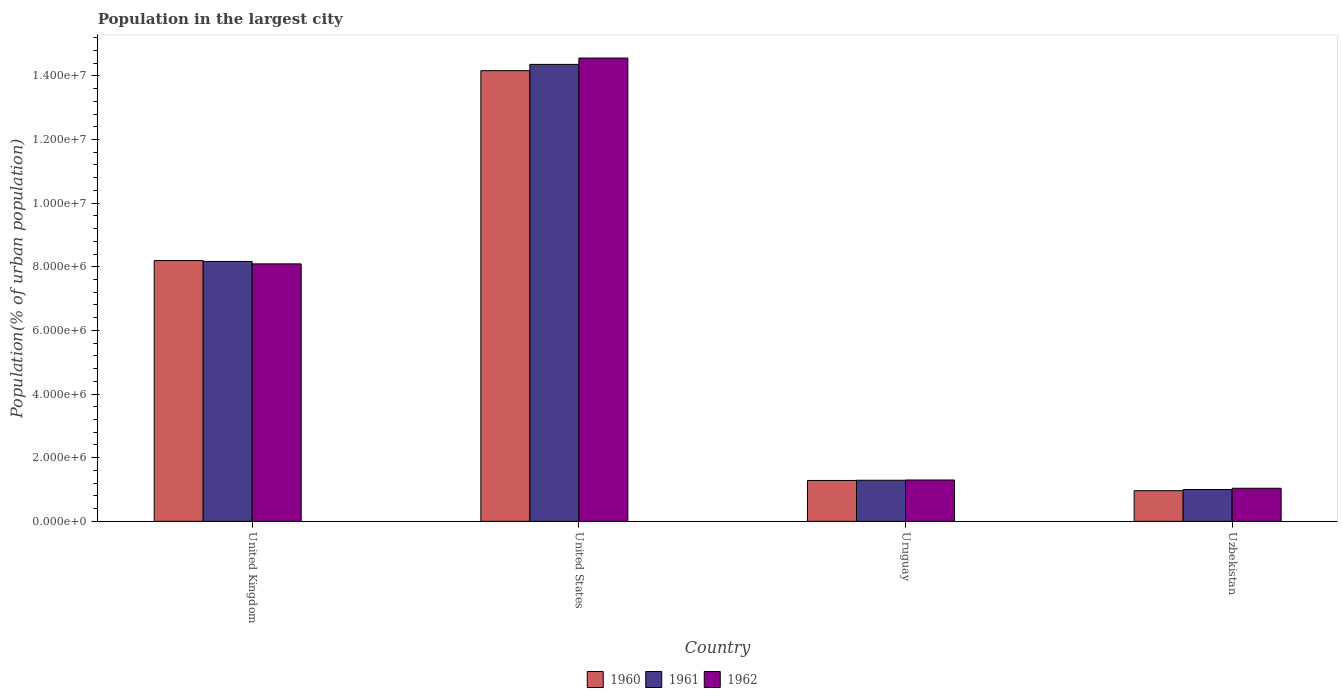Are the number of bars per tick equal to the number of legend labels?
Your answer should be very brief. Yes. Are the number of bars on each tick of the X-axis equal?
Offer a terse response. Yes. How many bars are there on the 1st tick from the left?
Give a very brief answer. 3. How many bars are there on the 2nd tick from the right?
Offer a terse response. 3. What is the label of the 1st group of bars from the left?
Keep it short and to the point. United Kingdom. In how many cases, is the number of bars for a given country not equal to the number of legend labels?
Provide a short and direct response. 0. What is the population in the largest city in 1961 in Uruguay?
Keep it short and to the point. 1.29e+06. Across all countries, what is the maximum population in the largest city in 1961?
Offer a terse response. 1.44e+07. Across all countries, what is the minimum population in the largest city in 1960?
Your answer should be very brief. 9.64e+05. In which country was the population in the largest city in 1962 minimum?
Keep it short and to the point. Uzbekistan. What is the total population in the largest city in 1960 in the graph?
Offer a terse response. 2.46e+07. What is the difference between the population in the largest city in 1960 in United Kingdom and that in Uruguay?
Ensure brevity in your answer.  6.91e+06. What is the difference between the population in the largest city in 1960 in United Kingdom and the population in the largest city in 1961 in Uruguay?
Offer a terse response. 6.90e+06. What is the average population in the largest city in 1961 per country?
Make the answer very short. 6.21e+06. What is the difference between the population in the largest city of/in 1962 and population in the largest city of/in 1960 in United States?
Give a very brief answer. 3.97e+05. What is the ratio of the population in the largest city in 1961 in Uruguay to that in Uzbekistan?
Keep it short and to the point. 1.29. Is the population in the largest city in 1962 in United Kingdom less than that in Uruguay?
Give a very brief answer. No. Is the difference between the population in the largest city in 1962 in Uruguay and Uzbekistan greater than the difference between the population in the largest city in 1960 in Uruguay and Uzbekistan?
Give a very brief answer. No. What is the difference between the highest and the second highest population in the largest city in 1960?
Provide a short and direct response. 5.97e+06. What is the difference between the highest and the lowest population in the largest city in 1960?
Your answer should be compact. 1.32e+07. Is the sum of the population in the largest city in 1961 in United Kingdom and United States greater than the maximum population in the largest city in 1960 across all countries?
Provide a short and direct response. Yes. What does the 3rd bar from the left in Uruguay represents?
Your answer should be very brief. 1962. What does the 3rd bar from the right in United States represents?
Offer a very short reply. 1960. Is it the case that in every country, the sum of the population in the largest city in 1960 and population in the largest city in 1961 is greater than the population in the largest city in 1962?
Provide a succinct answer. Yes. Are all the bars in the graph horizontal?
Offer a very short reply. No. What is the difference between two consecutive major ticks on the Y-axis?
Provide a short and direct response. 2.00e+06. Does the graph contain any zero values?
Your answer should be very brief. No. Does the graph contain grids?
Provide a succinct answer. No. Where does the legend appear in the graph?
Provide a short and direct response. Bottom center. How many legend labels are there?
Give a very brief answer. 3. How are the legend labels stacked?
Your response must be concise. Horizontal. What is the title of the graph?
Make the answer very short. Population in the largest city. What is the label or title of the Y-axis?
Offer a terse response. Population(% of urban population). What is the Population(% of urban population) of 1960 in United Kingdom?
Provide a succinct answer. 8.20e+06. What is the Population(% of urban population) of 1961 in United Kingdom?
Keep it short and to the point. 8.17e+06. What is the Population(% of urban population) of 1962 in United Kingdom?
Offer a very short reply. 8.09e+06. What is the Population(% of urban population) of 1960 in United States?
Your answer should be compact. 1.42e+07. What is the Population(% of urban population) in 1961 in United States?
Offer a terse response. 1.44e+07. What is the Population(% of urban population) in 1962 in United States?
Your response must be concise. 1.46e+07. What is the Population(% of urban population) of 1960 in Uruguay?
Ensure brevity in your answer.  1.28e+06. What is the Population(% of urban population) of 1961 in Uruguay?
Offer a terse response. 1.29e+06. What is the Population(% of urban population) of 1962 in Uruguay?
Ensure brevity in your answer.  1.30e+06. What is the Population(% of urban population) of 1960 in Uzbekistan?
Provide a short and direct response. 9.64e+05. What is the Population(% of urban population) in 1961 in Uzbekistan?
Make the answer very short. 1.00e+06. What is the Population(% of urban population) in 1962 in Uzbekistan?
Keep it short and to the point. 1.04e+06. Across all countries, what is the maximum Population(% of urban population) of 1960?
Give a very brief answer. 1.42e+07. Across all countries, what is the maximum Population(% of urban population) of 1961?
Offer a terse response. 1.44e+07. Across all countries, what is the maximum Population(% of urban population) of 1962?
Keep it short and to the point. 1.46e+07. Across all countries, what is the minimum Population(% of urban population) in 1960?
Your response must be concise. 9.64e+05. Across all countries, what is the minimum Population(% of urban population) in 1961?
Provide a short and direct response. 1.00e+06. Across all countries, what is the minimum Population(% of urban population) in 1962?
Your answer should be compact. 1.04e+06. What is the total Population(% of urban population) in 1960 in the graph?
Keep it short and to the point. 2.46e+07. What is the total Population(% of urban population) in 1961 in the graph?
Provide a succinct answer. 2.48e+07. What is the total Population(% of urban population) of 1962 in the graph?
Your response must be concise. 2.50e+07. What is the difference between the Population(% of urban population) in 1960 in United Kingdom and that in United States?
Make the answer very short. -5.97e+06. What is the difference between the Population(% of urban population) of 1961 in United Kingdom and that in United States?
Your answer should be compact. -6.19e+06. What is the difference between the Population(% of urban population) of 1962 in United Kingdom and that in United States?
Offer a very short reply. -6.47e+06. What is the difference between the Population(% of urban population) of 1960 in United Kingdom and that in Uruguay?
Give a very brief answer. 6.91e+06. What is the difference between the Population(% of urban population) in 1961 in United Kingdom and that in Uruguay?
Keep it short and to the point. 6.88e+06. What is the difference between the Population(% of urban population) of 1962 in United Kingdom and that in Uruguay?
Provide a short and direct response. 6.79e+06. What is the difference between the Population(% of urban population) in 1960 in United Kingdom and that in Uzbekistan?
Your answer should be compact. 7.23e+06. What is the difference between the Population(% of urban population) of 1961 in United Kingdom and that in Uzbekistan?
Your answer should be compact. 7.17e+06. What is the difference between the Population(% of urban population) of 1962 in United Kingdom and that in Uzbekistan?
Your response must be concise. 7.05e+06. What is the difference between the Population(% of urban population) in 1960 in United States and that in Uruguay?
Offer a terse response. 1.29e+07. What is the difference between the Population(% of urban population) of 1961 in United States and that in Uruguay?
Offer a very short reply. 1.31e+07. What is the difference between the Population(% of urban population) in 1962 in United States and that in Uruguay?
Ensure brevity in your answer.  1.33e+07. What is the difference between the Population(% of urban population) in 1960 in United States and that in Uzbekistan?
Your answer should be very brief. 1.32e+07. What is the difference between the Population(% of urban population) of 1961 in United States and that in Uzbekistan?
Make the answer very short. 1.34e+07. What is the difference between the Population(% of urban population) in 1962 in United States and that in Uzbekistan?
Provide a short and direct response. 1.35e+07. What is the difference between the Population(% of urban population) in 1960 in Uruguay and that in Uzbekistan?
Your response must be concise. 3.21e+05. What is the difference between the Population(% of urban population) in 1961 in Uruguay and that in Uzbekistan?
Provide a short and direct response. 2.91e+05. What is the difference between the Population(% of urban population) in 1962 in Uruguay and that in Uzbekistan?
Offer a terse response. 2.60e+05. What is the difference between the Population(% of urban population) in 1960 in United Kingdom and the Population(% of urban population) in 1961 in United States?
Make the answer very short. -6.16e+06. What is the difference between the Population(% of urban population) in 1960 in United Kingdom and the Population(% of urban population) in 1962 in United States?
Make the answer very short. -6.36e+06. What is the difference between the Population(% of urban population) in 1961 in United Kingdom and the Population(% of urban population) in 1962 in United States?
Your response must be concise. -6.39e+06. What is the difference between the Population(% of urban population) of 1960 in United Kingdom and the Population(% of urban population) of 1961 in Uruguay?
Offer a terse response. 6.90e+06. What is the difference between the Population(% of urban population) in 1960 in United Kingdom and the Population(% of urban population) in 1962 in Uruguay?
Provide a succinct answer. 6.90e+06. What is the difference between the Population(% of urban population) in 1961 in United Kingdom and the Population(% of urban population) in 1962 in Uruguay?
Offer a terse response. 6.87e+06. What is the difference between the Population(% of urban population) of 1960 in United Kingdom and the Population(% of urban population) of 1961 in Uzbekistan?
Give a very brief answer. 7.19e+06. What is the difference between the Population(% of urban population) of 1960 in United Kingdom and the Population(% of urban population) of 1962 in Uzbekistan?
Your answer should be very brief. 7.16e+06. What is the difference between the Population(% of urban population) in 1961 in United Kingdom and the Population(% of urban population) in 1962 in Uzbekistan?
Provide a succinct answer. 7.13e+06. What is the difference between the Population(% of urban population) of 1960 in United States and the Population(% of urban population) of 1961 in Uruguay?
Offer a terse response. 1.29e+07. What is the difference between the Population(% of urban population) in 1960 in United States and the Population(% of urban population) in 1962 in Uruguay?
Your answer should be very brief. 1.29e+07. What is the difference between the Population(% of urban population) in 1961 in United States and the Population(% of urban population) in 1962 in Uruguay?
Offer a terse response. 1.31e+07. What is the difference between the Population(% of urban population) in 1960 in United States and the Population(% of urban population) in 1961 in Uzbekistan?
Your response must be concise. 1.32e+07. What is the difference between the Population(% of urban population) in 1960 in United States and the Population(% of urban population) in 1962 in Uzbekistan?
Your answer should be compact. 1.31e+07. What is the difference between the Population(% of urban population) in 1961 in United States and the Population(% of urban population) in 1962 in Uzbekistan?
Give a very brief answer. 1.33e+07. What is the difference between the Population(% of urban population) in 1960 in Uruguay and the Population(% of urban population) in 1961 in Uzbekistan?
Make the answer very short. 2.84e+05. What is the difference between the Population(% of urban population) of 1960 in Uruguay and the Population(% of urban population) of 1962 in Uzbekistan?
Provide a succinct answer. 2.45e+05. What is the difference between the Population(% of urban population) in 1961 in Uruguay and the Population(% of urban population) in 1962 in Uzbekistan?
Provide a short and direct response. 2.53e+05. What is the average Population(% of urban population) in 1960 per country?
Provide a succinct answer. 6.15e+06. What is the average Population(% of urban population) of 1961 per country?
Offer a terse response. 6.21e+06. What is the average Population(% of urban population) of 1962 per country?
Give a very brief answer. 6.25e+06. What is the difference between the Population(% of urban population) of 1960 and Population(% of urban population) of 1961 in United Kingdom?
Your answer should be compact. 2.77e+04. What is the difference between the Population(% of urban population) of 1960 and Population(% of urban population) of 1962 in United Kingdom?
Offer a terse response. 1.04e+05. What is the difference between the Population(% of urban population) of 1961 and Population(% of urban population) of 1962 in United Kingdom?
Keep it short and to the point. 7.60e+04. What is the difference between the Population(% of urban population) of 1960 and Population(% of urban population) of 1961 in United States?
Your response must be concise. -1.97e+05. What is the difference between the Population(% of urban population) in 1960 and Population(% of urban population) in 1962 in United States?
Offer a terse response. -3.97e+05. What is the difference between the Population(% of urban population) in 1961 and Population(% of urban population) in 1962 in United States?
Your answer should be very brief. -2.00e+05. What is the difference between the Population(% of urban population) of 1960 and Population(% of urban population) of 1961 in Uruguay?
Keep it short and to the point. -7522. What is the difference between the Population(% of urban population) in 1960 and Population(% of urban population) in 1962 in Uruguay?
Your answer should be very brief. -1.51e+04. What is the difference between the Population(% of urban population) in 1961 and Population(% of urban population) in 1962 in Uruguay?
Provide a succinct answer. -7578. What is the difference between the Population(% of urban population) in 1960 and Population(% of urban population) in 1961 in Uzbekistan?
Give a very brief answer. -3.73e+04. What is the difference between the Population(% of urban population) in 1960 and Population(% of urban population) in 1962 in Uzbekistan?
Your answer should be compact. -7.60e+04. What is the difference between the Population(% of urban population) of 1961 and Population(% of urban population) of 1962 in Uzbekistan?
Provide a succinct answer. -3.88e+04. What is the ratio of the Population(% of urban population) in 1960 in United Kingdom to that in United States?
Keep it short and to the point. 0.58. What is the ratio of the Population(% of urban population) in 1961 in United Kingdom to that in United States?
Provide a short and direct response. 0.57. What is the ratio of the Population(% of urban population) in 1962 in United Kingdom to that in United States?
Keep it short and to the point. 0.56. What is the ratio of the Population(% of urban population) in 1960 in United Kingdom to that in Uruguay?
Offer a very short reply. 6.38. What is the ratio of the Population(% of urban population) of 1961 in United Kingdom to that in Uruguay?
Provide a short and direct response. 6.32. What is the ratio of the Population(% of urban population) of 1962 in United Kingdom to that in Uruguay?
Your answer should be very brief. 6.22. What is the ratio of the Population(% of urban population) in 1960 in United Kingdom to that in Uzbekistan?
Offer a very short reply. 8.5. What is the ratio of the Population(% of urban population) in 1961 in United Kingdom to that in Uzbekistan?
Provide a short and direct response. 8.16. What is the ratio of the Population(% of urban population) in 1962 in United Kingdom to that in Uzbekistan?
Offer a terse response. 7.78. What is the ratio of the Population(% of urban population) of 1960 in United States to that in Uruguay?
Give a very brief answer. 11.02. What is the ratio of the Population(% of urban population) in 1961 in United States to that in Uruguay?
Your answer should be compact. 11.11. What is the ratio of the Population(% of urban population) of 1962 in United States to that in Uruguay?
Offer a terse response. 11.2. What is the ratio of the Population(% of urban population) in 1960 in United States to that in Uzbekistan?
Ensure brevity in your answer.  14.69. What is the ratio of the Population(% of urban population) in 1961 in United States to that in Uzbekistan?
Provide a succinct answer. 14.34. What is the ratio of the Population(% of urban population) of 1962 in United States to that in Uzbekistan?
Keep it short and to the point. 14. What is the ratio of the Population(% of urban population) in 1960 in Uruguay to that in Uzbekistan?
Provide a short and direct response. 1.33. What is the ratio of the Population(% of urban population) of 1961 in Uruguay to that in Uzbekistan?
Your answer should be very brief. 1.29. What is the ratio of the Population(% of urban population) in 1962 in Uruguay to that in Uzbekistan?
Provide a short and direct response. 1.25. What is the difference between the highest and the second highest Population(% of urban population) of 1960?
Your response must be concise. 5.97e+06. What is the difference between the highest and the second highest Population(% of urban population) of 1961?
Make the answer very short. 6.19e+06. What is the difference between the highest and the second highest Population(% of urban population) of 1962?
Your response must be concise. 6.47e+06. What is the difference between the highest and the lowest Population(% of urban population) of 1960?
Provide a succinct answer. 1.32e+07. What is the difference between the highest and the lowest Population(% of urban population) of 1961?
Provide a short and direct response. 1.34e+07. What is the difference between the highest and the lowest Population(% of urban population) of 1962?
Your answer should be very brief. 1.35e+07. 